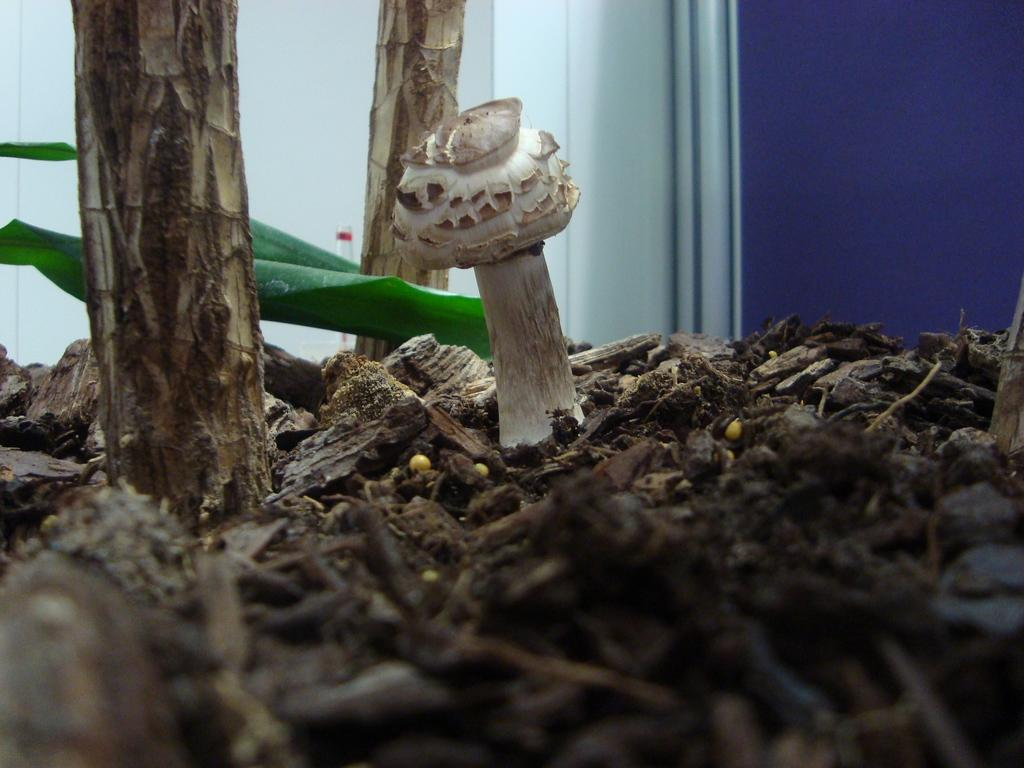What is the main subject of the image? There is a mushroom in the image. How is the mushroom positioned in relation to other objects? The mushroom is located between twigs. What can be seen in the background of the image? There are walls, a branch, and leaves visible in the background of the image. Can you hear the ear of the snail in the image? There is no snail or ear present in the image; it features a mushroom between twigs and a background with walls, a branch, and leaves. 